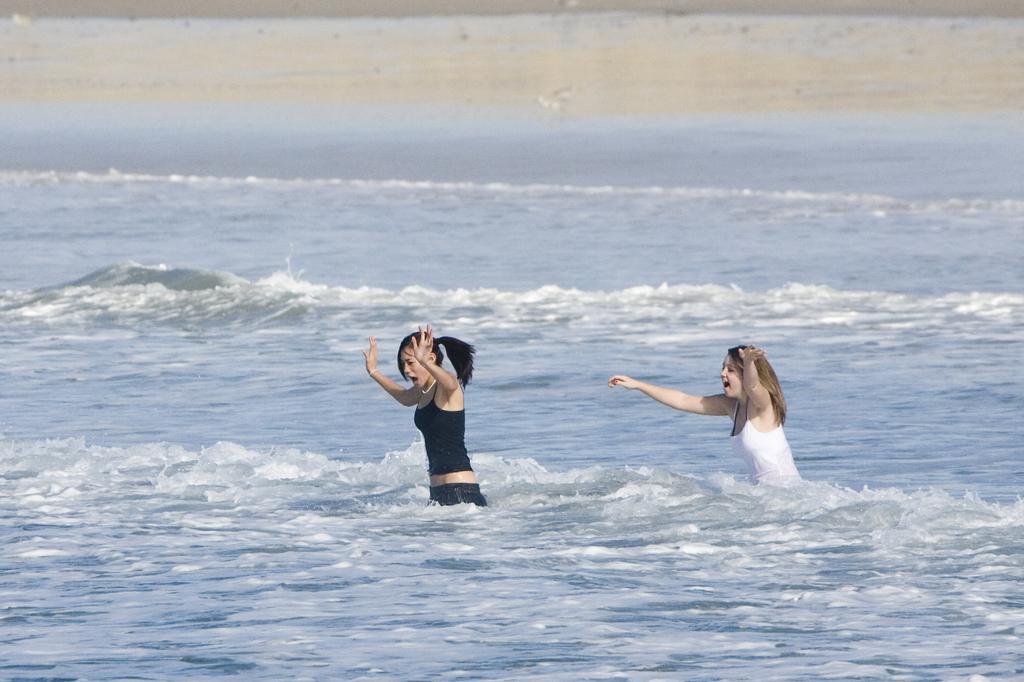In one or two sentences, can you explain what this image depicts? In this image there are two girls standing in the water and playing with it. 